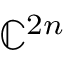<formula> <loc_0><loc_0><loc_500><loc_500>\mathbb { C } ^ { 2 n }</formula> 